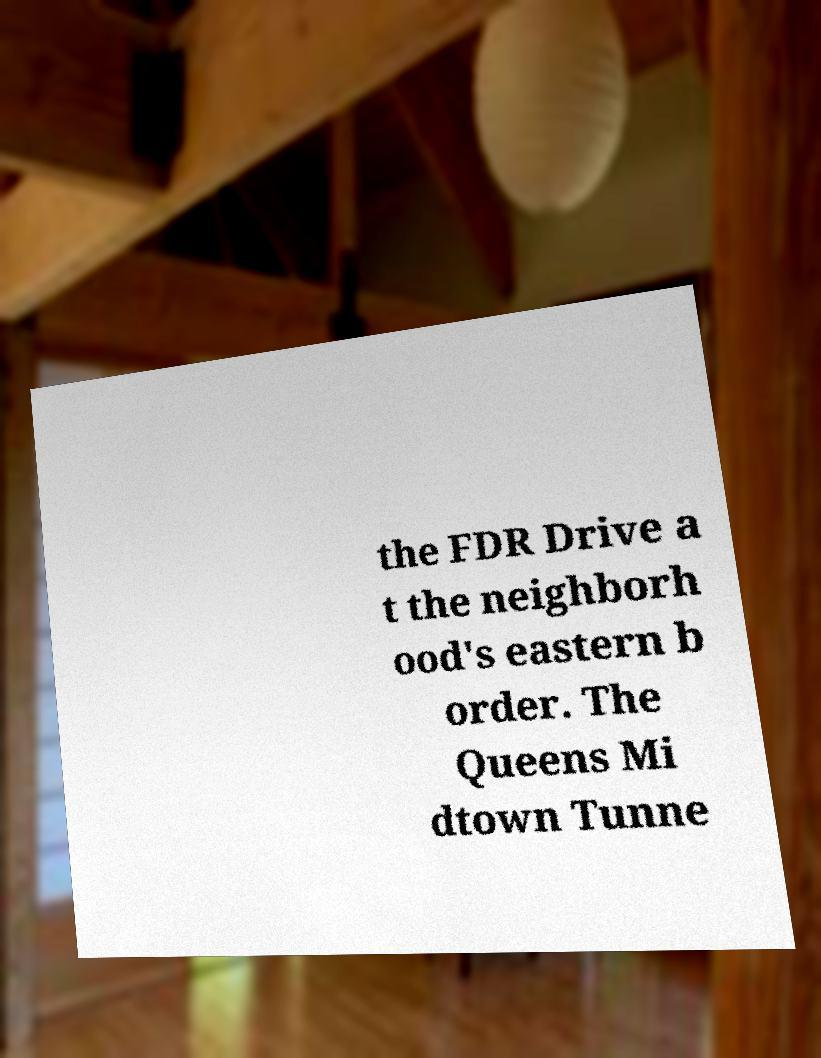Please read and relay the text visible in this image. What does it say? the FDR Drive a t the neighborh ood's eastern b order. The Queens Mi dtown Tunne 